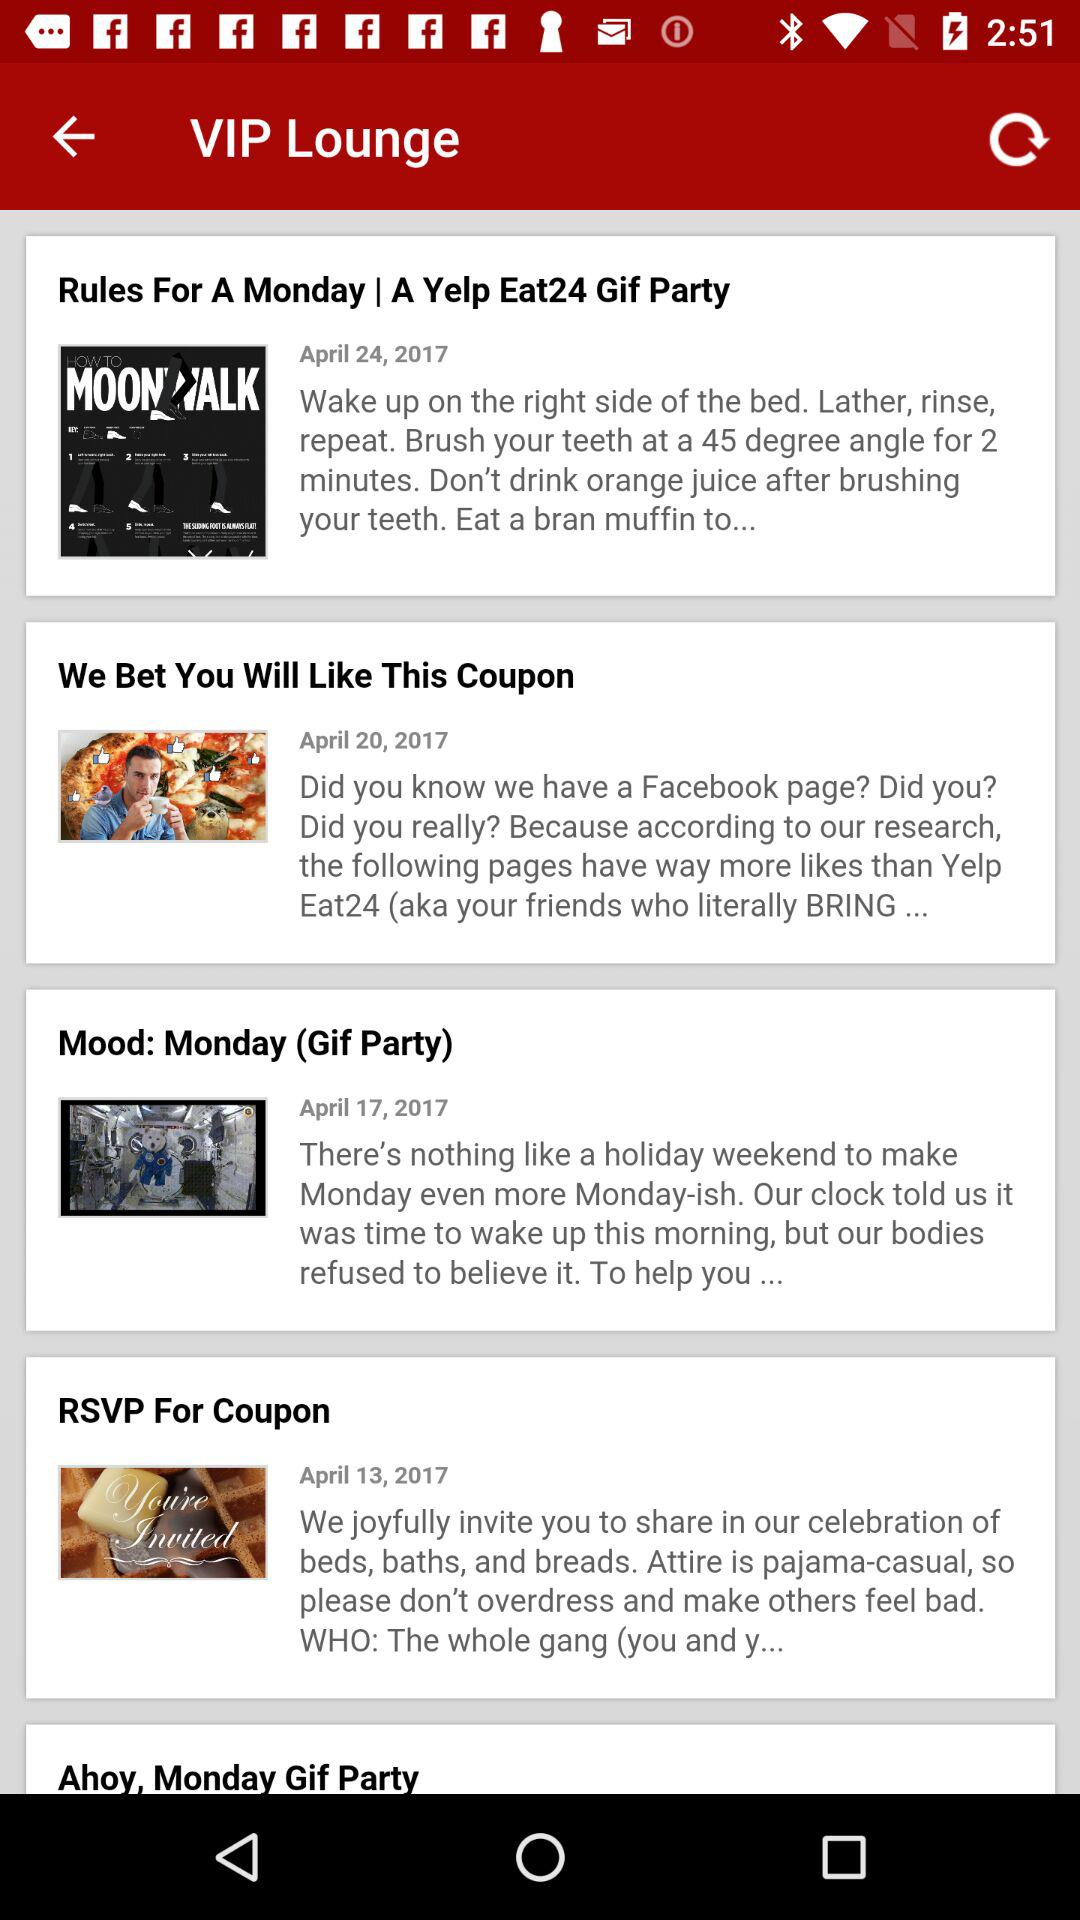Which article was published on April 13, 2017? The article was "RSVP For Coupon". 